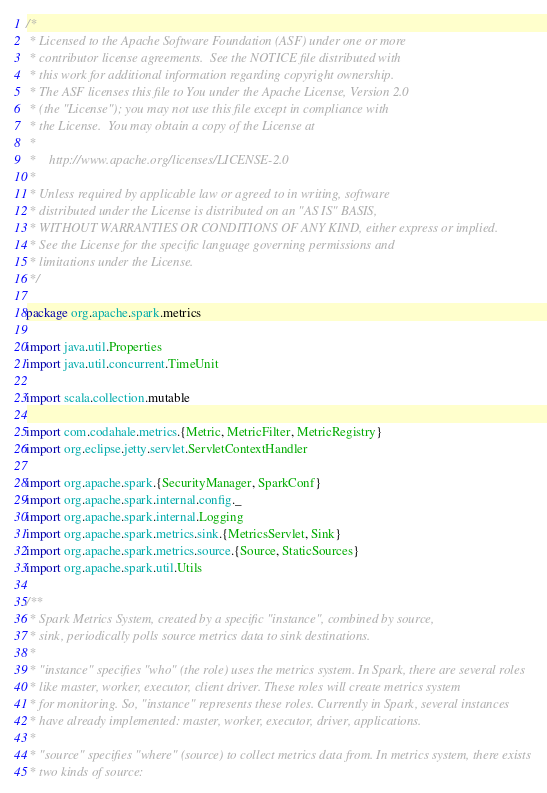Convert code to text. <code><loc_0><loc_0><loc_500><loc_500><_Scala_>/*
 * Licensed to the Apache Software Foundation (ASF) under one or more
 * contributor license agreements.  See the NOTICE file distributed with
 * this work for additional information regarding copyright ownership.
 * The ASF licenses this file to You under the Apache License, Version 2.0
 * (the "License"); you may not use this file except in compliance with
 * the License.  You may obtain a copy of the License at
 *
 *    http://www.apache.org/licenses/LICENSE-2.0
 *
 * Unless required by applicable law or agreed to in writing, software
 * distributed under the License is distributed on an "AS IS" BASIS,
 * WITHOUT WARRANTIES OR CONDITIONS OF ANY KIND, either express or implied.
 * See the License for the specific language governing permissions and
 * limitations under the License.
 */

package org.apache.spark.metrics

import java.util.Properties
import java.util.concurrent.TimeUnit

import scala.collection.mutable

import com.codahale.metrics.{Metric, MetricFilter, MetricRegistry}
import org.eclipse.jetty.servlet.ServletContextHandler

import org.apache.spark.{SecurityManager, SparkConf}
import org.apache.spark.internal.config._
import org.apache.spark.internal.Logging
import org.apache.spark.metrics.sink.{MetricsServlet, Sink}
import org.apache.spark.metrics.source.{Source, StaticSources}
import org.apache.spark.util.Utils

/**
 * Spark Metrics System, created by a specific "instance", combined by source,
 * sink, periodically polls source metrics data to sink destinations.
 *
 * "instance" specifies "who" (the role) uses the metrics system. In Spark, there are several roles
 * like master, worker, executor, client driver. These roles will create metrics system
 * for monitoring. So, "instance" represents these roles. Currently in Spark, several instances
 * have already implemented: master, worker, executor, driver, applications.
 *
 * "source" specifies "where" (source) to collect metrics data from. In metrics system, there exists
 * two kinds of source:</code> 